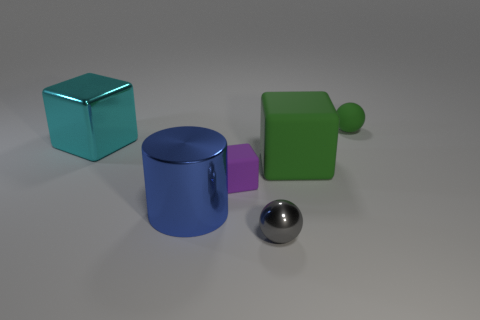How would you describe the arrangement of the objects? The objects are arranged in a somewhat scattered manner on a flat surface, with no apparent order. The blue cube is upright, the purple cylinder is on its side, the large green cube is tilted, and the small green sphere is in a forward position from the center.  Are there any patterns or repetitions in this scene? There are no explicit patterns or repetitions in the image. Each object is unique in shape and color, except for the small sphere and the large block that share the same color. 